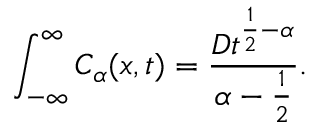<formula> <loc_0><loc_0><loc_500><loc_500>\int _ { - \infty } ^ { \infty } C _ { \alpha } ( x , t ) = \frac { D t ^ { \frac { 1 } { 2 } - \alpha } } { \alpha - \frac { 1 } { 2 } } .</formula> 